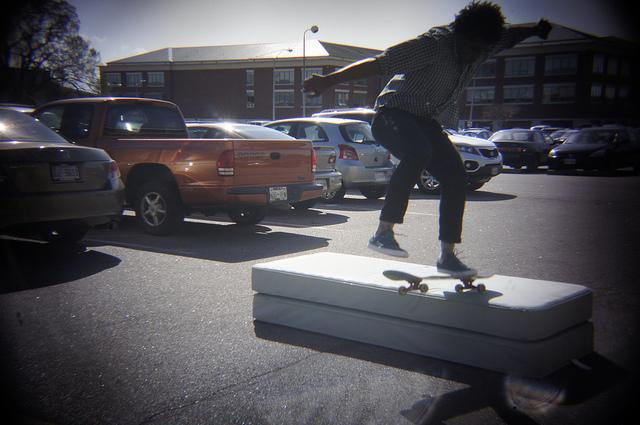What model is the orange truck?
Be succinct. Dodge. Is he in a parking lot?
Be succinct. Yes. Are both of the skater's feet on the board?
Concise answer only. No. 